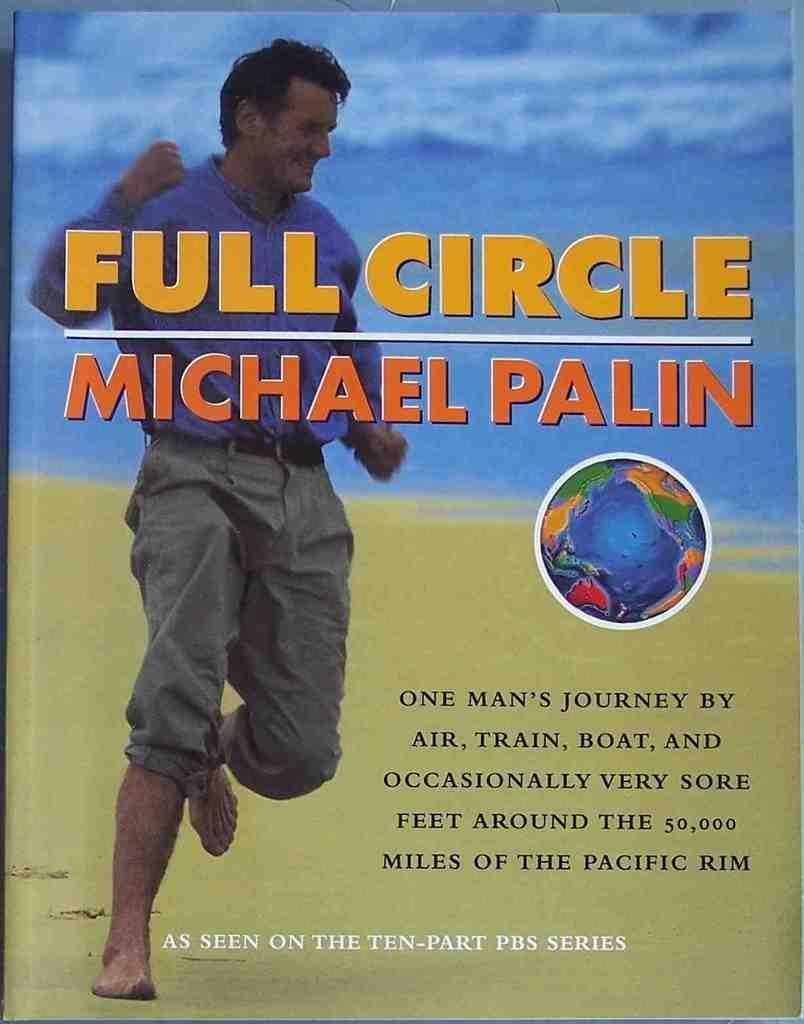In one or two sentences, can you explain what this image depicts? In this picture we can see an object seems to be a poster. On the left we can see a person seems to be running and we the picture of a globe and we can see the text. In the background we can see the sky and some other objects. 